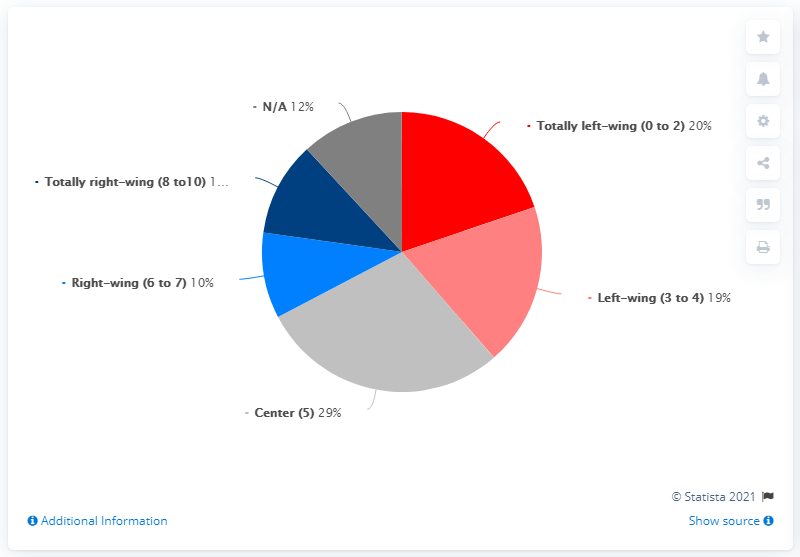Point out several critical features in this image. It is indicated by blue. In comparison to the Left wing, the Right wing has a difference of 10%, indicating that the Right wing is more conservative than the Left wing. The Center is characterized as having a 5% difference from both the Left and Right wings, indicating that it is more moderate than both the Left and Right wings. 